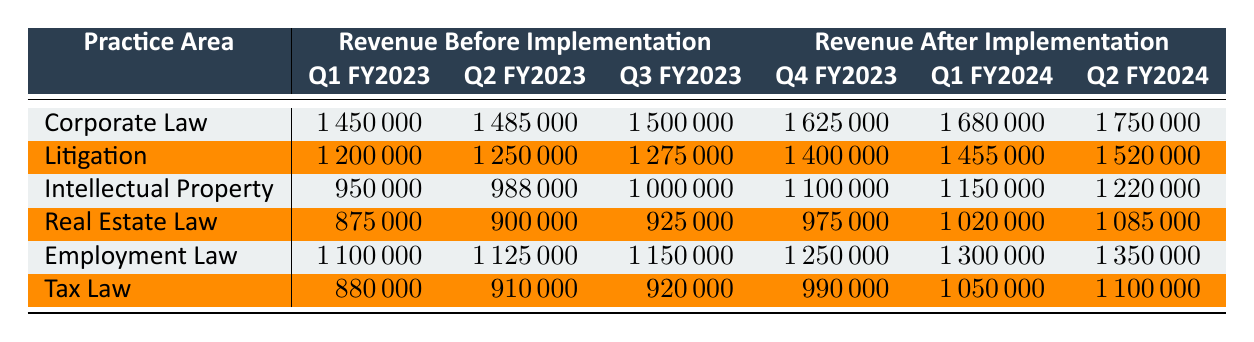What was the revenue for Corporate Law in Q1 FY2023? The table shows the column for Revenue Before Implementation under Corporate Law, where Q1 FY2023 is listed as 1,450,000.
Answer: 1,450,000 How much revenue did Litigation generate in Q2 FY2024? Looking at the Revenue After Implementation section for Litigation, Q2 FY2024 is shown to be 1,520,000.
Answer: 1,520,000 Which practice area saw the highest revenue increase from Q3 FY2023 to Q4 FY2023? To find the highest increase, we compare the revenue for each area from Q3 FY2023 to Q4 FY2023: Corporate Law increased by 125,000, Litigation by 125,000, Intellectual Property by 100,000, Real Estate Law by 50,000, Employment Law by 100,000, and Tax Law by 70,000. Corporate Law and Litigation both saw the highest increase of 125,000.
Answer: Corporate Law and Litigation What is the total revenue generated by Intellectual Property in Q1 FY2024 and Q2 FY2024? The revenue for Intellectual Property in Q1 FY2024 is 1,150,000 and in Q2 FY2024 is 1,220,000. Adding these two amounts results in 1,150,000 + 1,220,000 = 2,370,000.
Answer: 2,370,000 Is the revenue generated by Employment Law in Q1 FY2024 greater than the revenue in Q2 FY2023? The revenue for Employment Law in Q1 FY2024 is 1,300,000 and in Q2 FY2023 is 1,125,000. Since 1,300,000 is greater than 1,125,000, the answer is yes.
Answer: Yes What is the average revenue per quarter for Real Estate Law after software implementation? The revenue after implementation for Real Estate Law is 975,000 in Q4 FY2023, 1,020,000 in Q1 FY2024, and 1,085,000 in Q2 FY2024. The average is calculated as (975,000 + 1,020,000 + 1,085,000) / 3 = 1,026,667.
Answer: 1,026,667 Did Tax Law's revenue exceed 1,000,000 in any quarter after implementation? The revenue for Tax Law after implementation shows amounts of 990,000 in Q4 FY2023, 1,050,000 in Q1 FY2024, and 1,100,000 in Q2 FY2024. Since 990,000 does not exceed 1,000,000, but the other two do, the answer is yes.
Answer: Yes Which practice area had the lowest revenue in Q2 FY2023? Reviewing the table, the revenue for each practice area in Q2 FY2023 shows: Corporate Law (1,485,000), Litigation (1,250,000), Intellectual Property (988,000), Real Estate Law (900,000), Employment Law (1,125,000), and Tax Law (910,000). The lowest is Intellectual Property with 988,000.
Answer: Intellectual Property 